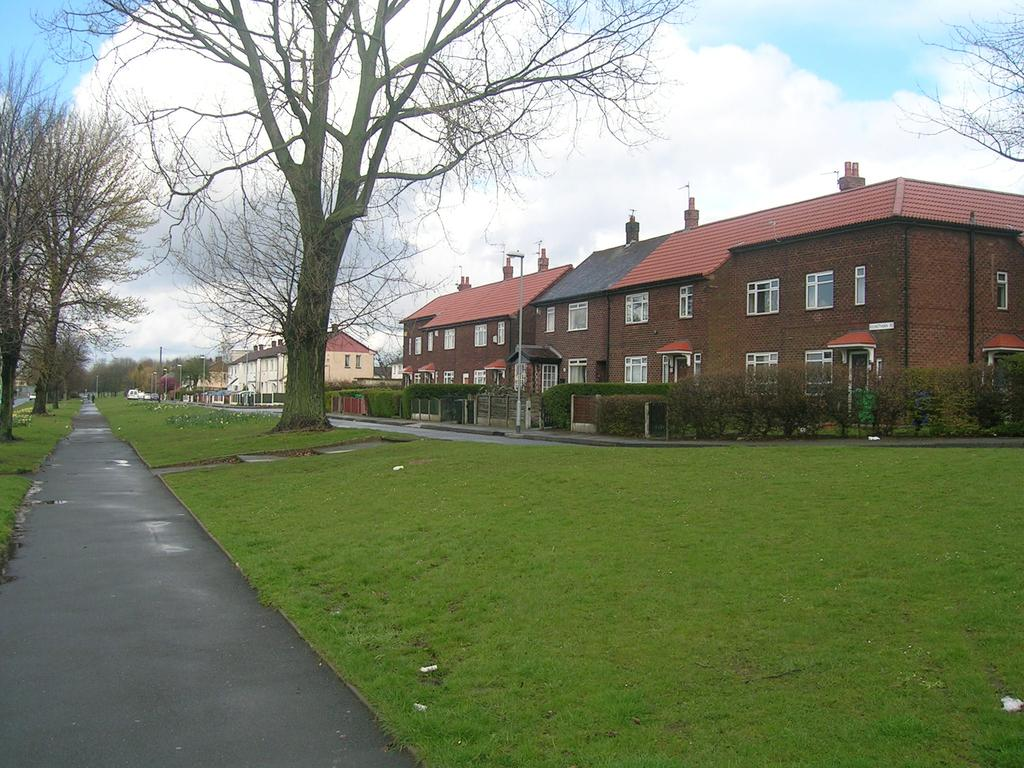What type of structure is present in the image? There is a house in the image. What features can be observed on the house? The house has a roof and windows. What is the boundary surrounding the house? There is a fence in the image. What type of vegetation is present in the image? There are plants, grass, and trees in the image. What other objects can be seen in the image? There are poles and a road in the image. What is the condition of the sky in the image? The sky is visible in the image and appears cloudy. What time of day is it in the image, and is everyone wearing their coats? The time of day cannot be determined from the image, and there is no information about people wearing coats. 